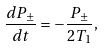Convert formula to latex. <formula><loc_0><loc_0><loc_500><loc_500>\frac { d P _ { \pm } } { d t } = - \frac { P _ { \pm } } { 2 T _ { 1 } } ,</formula> 